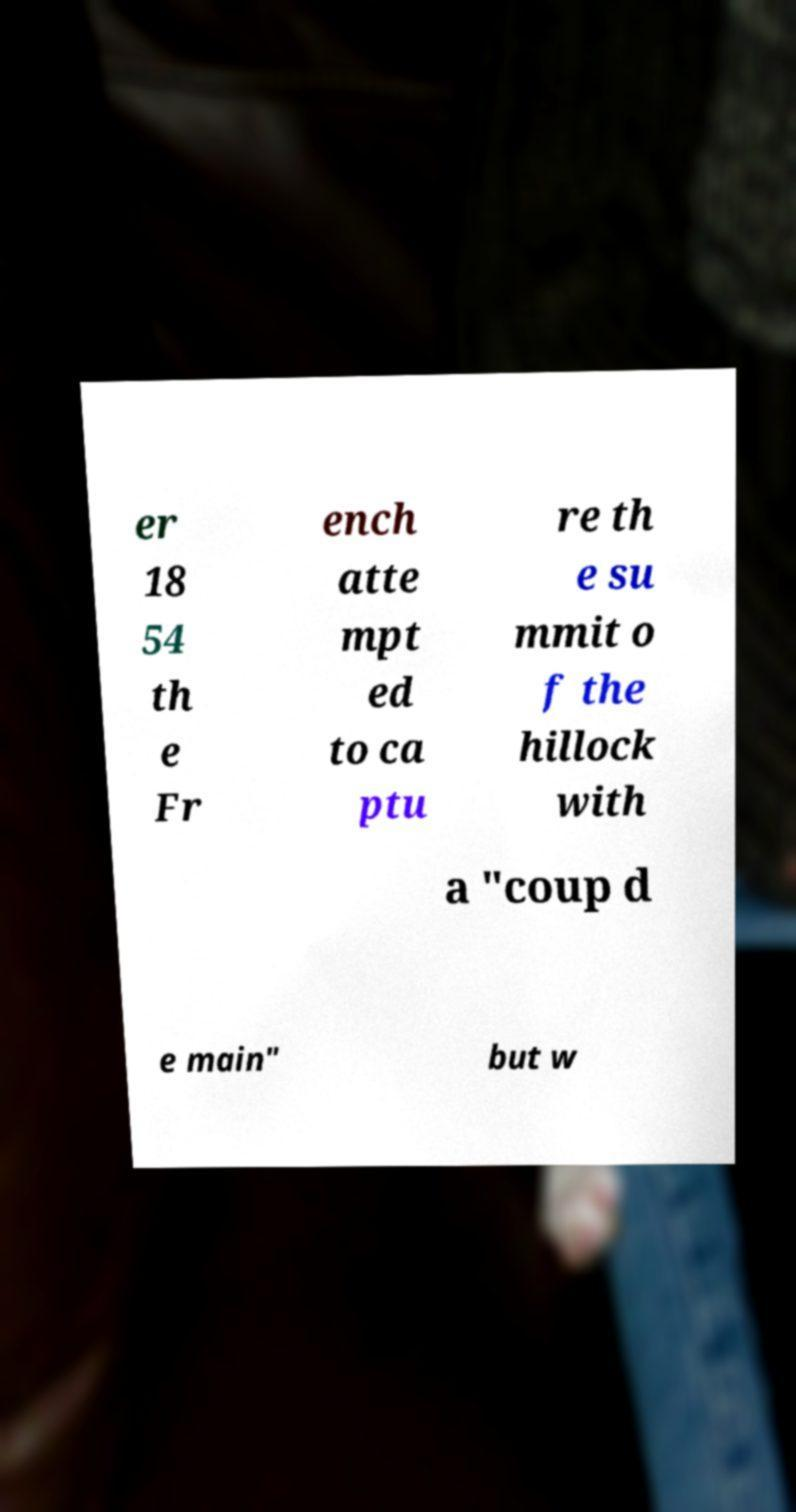Please read and relay the text visible in this image. What does it say? er 18 54 th e Fr ench atte mpt ed to ca ptu re th e su mmit o f the hillock with a "coup d e main" but w 